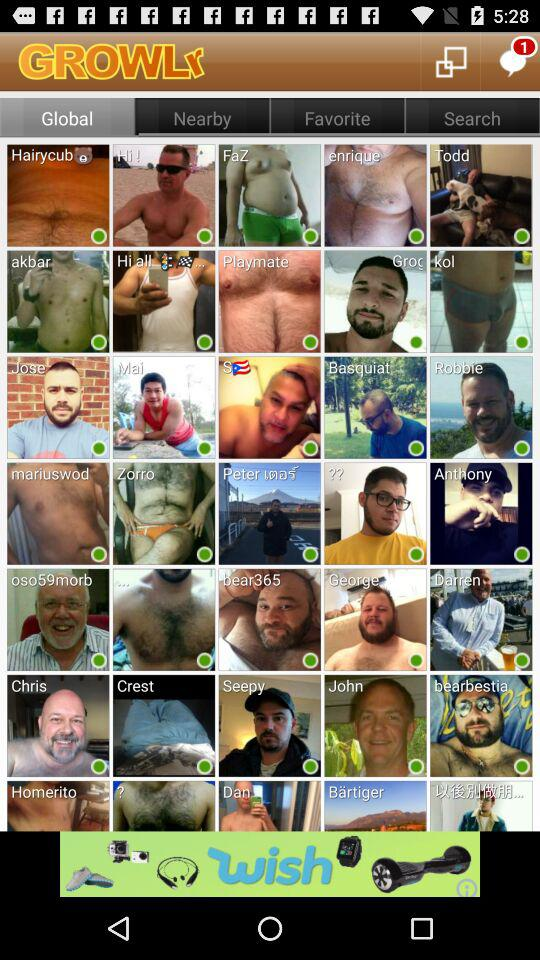Which tab has been selected? The selected tab is "Global". 